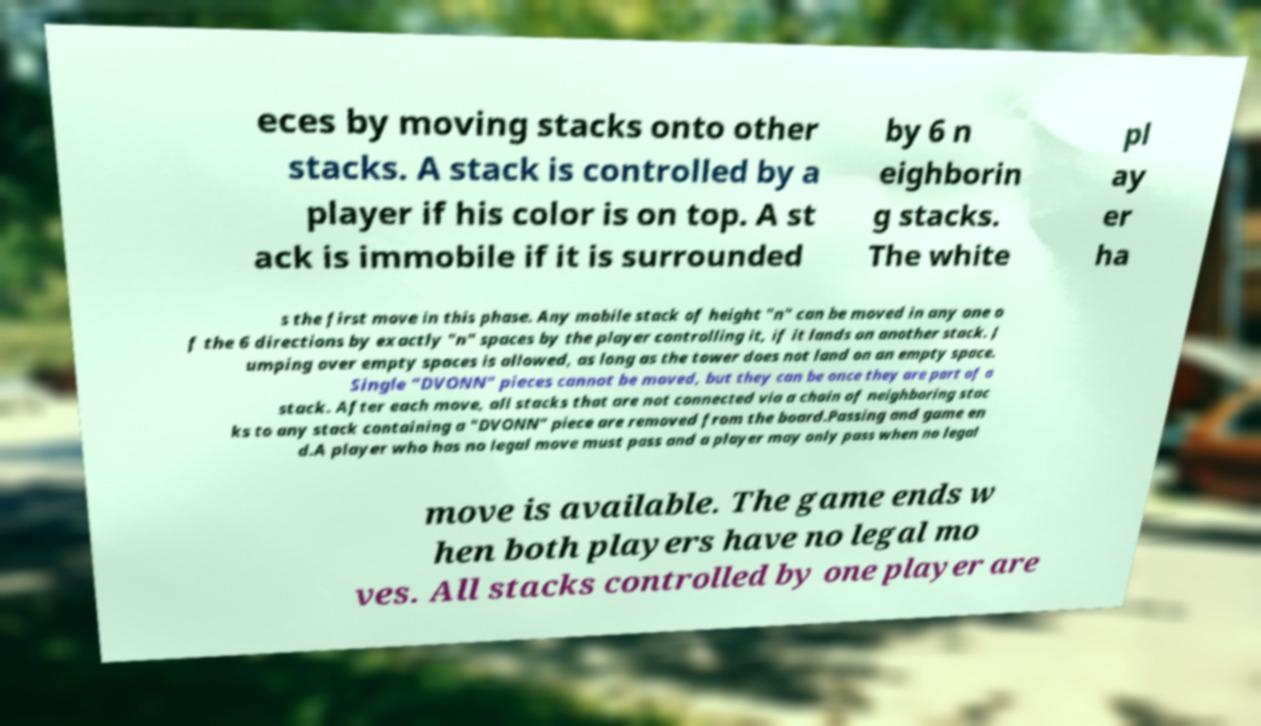Could you extract and type out the text from this image? eces by moving stacks onto other stacks. A stack is controlled by a player if his color is on top. A st ack is immobile if it is surrounded by 6 n eighborin g stacks. The white pl ay er ha s the first move in this phase. Any mobile stack of height "n" can be moved in any one o f the 6 directions by exactly "n" spaces by the player controlling it, if it lands on another stack. J umping over empty spaces is allowed, as long as the tower does not land on an empty space. Single "DVONN" pieces cannot be moved, but they can be once they are part of a stack. After each move, all stacks that are not connected via a chain of neighboring stac ks to any stack containing a "DVONN" piece are removed from the board.Passing and game en d.A player who has no legal move must pass and a player may only pass when no legal move is available. The game ends w hen both players have no legal mo ves. All stacks controlled by one player are 